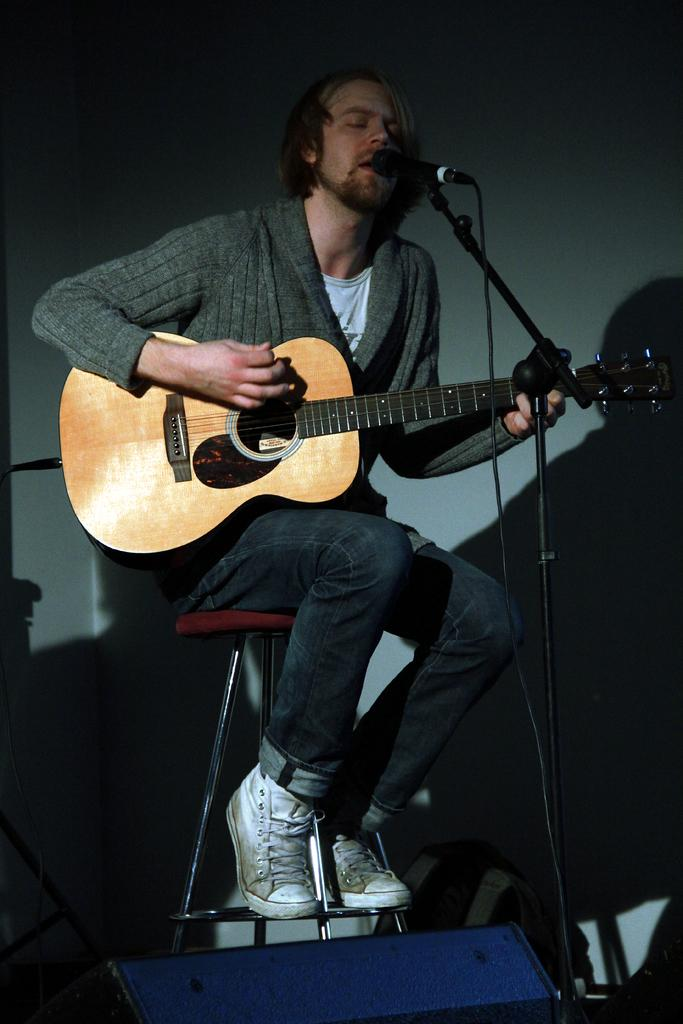Who is present in the image? There is a man in the image. What is the man doing in the image? The man is sitting on a stool and holding a guitar. What equipment is visible in the image? There is a microphone with a microphone stand in the image. What can be seen in the background of the image? There is a wall in the background of the image. What type of jewel is the man wearing on his neck in the image? There is no jewel visible on the man's neck in the image. 